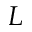<formula> <loc_0><loc_0><loc_500><loc_500>L</formula> 